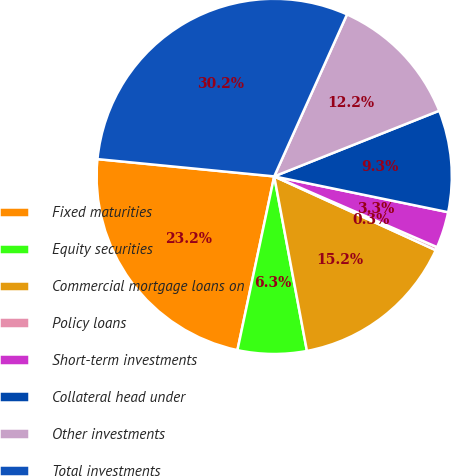<chart> <loc_0><loc_0><loc_500><loc_500><pie_chart><fcel>Fixed maturities<fcel>Equity securities<fcel>Commercial mortgage loans on<fcel>Policy loans<fcel>Short-term investments<fcel>Collateral head under<fcel>Other investments<fcel>Total investments<nl><fcel>23.23%<fcel>6.27%<fcel>15.23%<fcel>0.3%<fcel>3.29%<fcel>9.26%<fcel>12.25%<fcel>30.17%<nl></chart> 